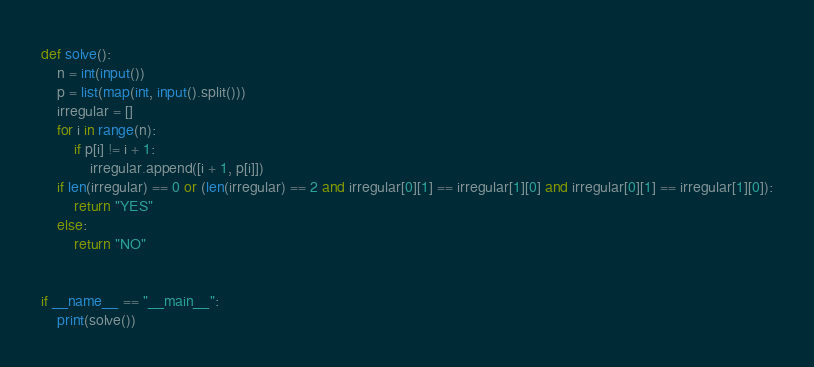Convert code to text. <code><loc_0><loc_0><loc_500><loc_500><_Python_>def solve():
    n = int(input())
    p = list(map(int, input().split()))
    irregular = []
    for i in range(n):
        if p[i] != i + 1:
            irregular.append([i + 1, p[i]])
    if len(irregular) == 0 or (len(irregular) == 2 and irregular[0][1] == irregular[1][0] and irregular[0][1] == irregular[1][0]):
        return "YES"
    else:
        return "NO"


if __name__ == "__main__":
    print(solve())
</code> 